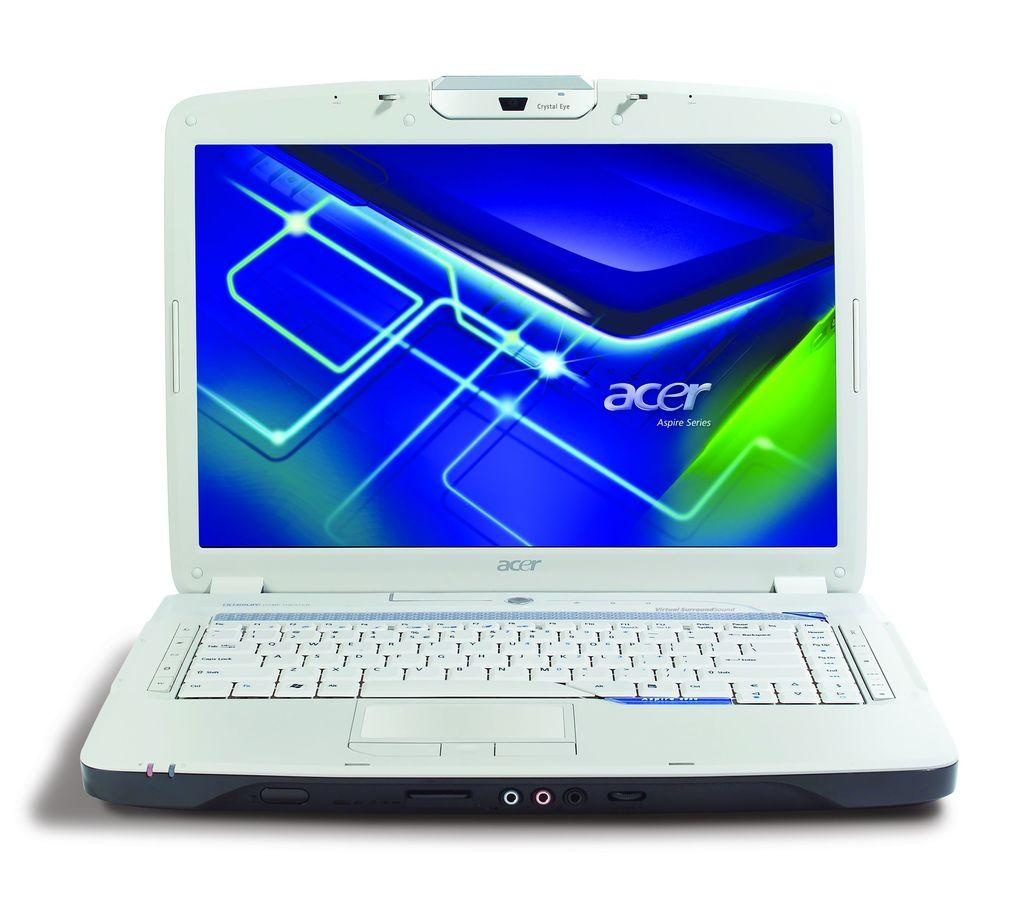<image>
Create a compact narrative representing the image presented. A white acer laptop on a white background. 